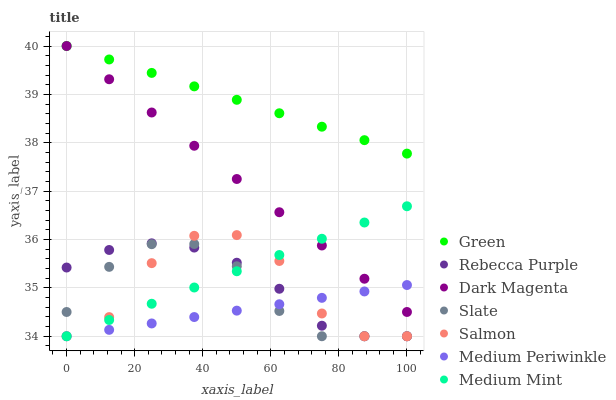Does Medium Periwinkle have the minimum area under the curve?
Answer yes or no. Yes. Does Green have the maximum area under the curve?
Answer yes or no. Yes. Does Dark Magenta have the minimum area under the curve?
Answer yes or no. No. Does Dark Magenta have the maximum area under the curve?
Answer yes or no. No. Is Green the smoothest?
Answer yes or no. Yes. Is Salmon the roughest?
Answer yes or no. Yes. Is Dark Magenta the smoothest?
Answer yes or no. No. Is Dark Magenta the roughest?
Answer yes or no. No. Does Medium Mint have the lowest value?
Answer yes or no. Yes. Does Dark Magenta have the lowest value?
Answer yes or no. No. Does Green have the highest value?
Answer yes or no. Yes. Does Medium Periwinkle have the highest value?
Answer yes or no. No. Is Salmon less than Green?
Answer yes or no. Yes. Is Dark Magenta greater than Salmon?
Answer yes or no. Yes. Does Dark Magenta intersect Green?
Answer yes or no. Yes. Is Dark Magenta less than Green?
Answer yes or no. No. Is Dark Magenta greater than Green?
Answer yes or no. No. Does Salmon intersect Green?
Answer yes or no. No. 